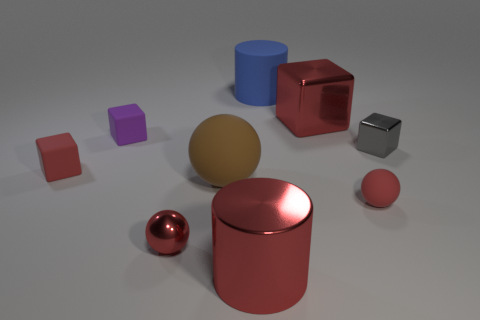Do the large metallic cube and the metallic cylinder have the same color?
Give a very brief answer. Yes. There is a shiny cylinder that is the same color as the large block; what is its size?
Your answer should be compact. Large. What number of objects are either small green metal spheres or purple objects?
Keep it short and to the point. 1. There is a red cube that is left of the small rubber block to the right of the red rubber cube; what is its material?
Your answer should be compact. Rubber. Is there a big shiny cylinder of the same color as the large shiny cube?
Provide a succinct answer. Yes. There is a metallic sphere that is the same size as the purple rubber cube; what is its color?
Provide a succinct answer. Red. What material is the large red thing on the right side of the big cylinder in front of the red rubber thing on the right side of the purple block?
Provide a succinct answer. Metal. Does the tiny metal sphere have the same color as the cylinder in front of the tiny rubber ball?
Give a very brief answer. Yes. What number of things are either small blocks right of the large blue rubber cylinder or large things that are behind the red shiny cylinder?
Offer a terse response. 4. What shape is the big thing that is in front of the tiny red sphere left of the tiny red matte ball?
Your answer should be very brief. Cylinder. 